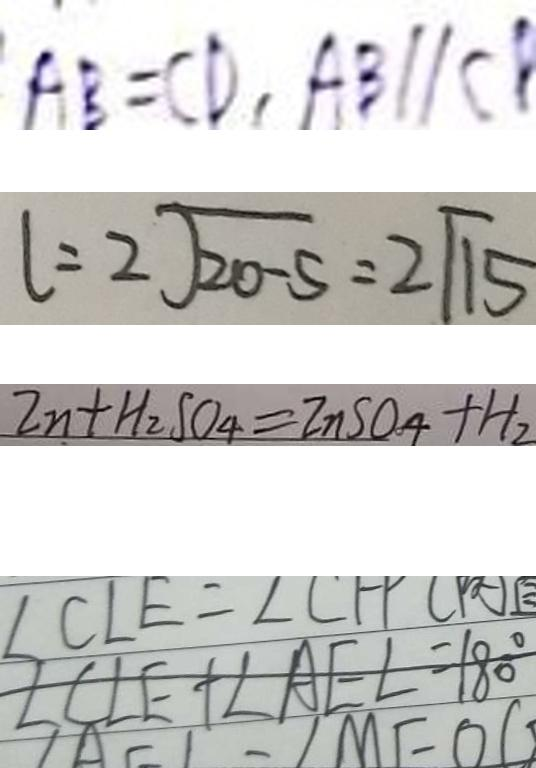Convert formula to latex. <formula><loc_0><loc_0><loc_500><loc_500>A B = C D , A B / / C B 
 l = 2 \sqrt { 2 0 - 5 } = 2 \sqrt { 1 5 } 
 2 n + H _ { 2 } S O _ { 4 } = 2 n S O _ { 4 } + H _ { 2 } 
 \angle C L E + \angle A E L = 1 8 0 ^ { \circ }</formula> 